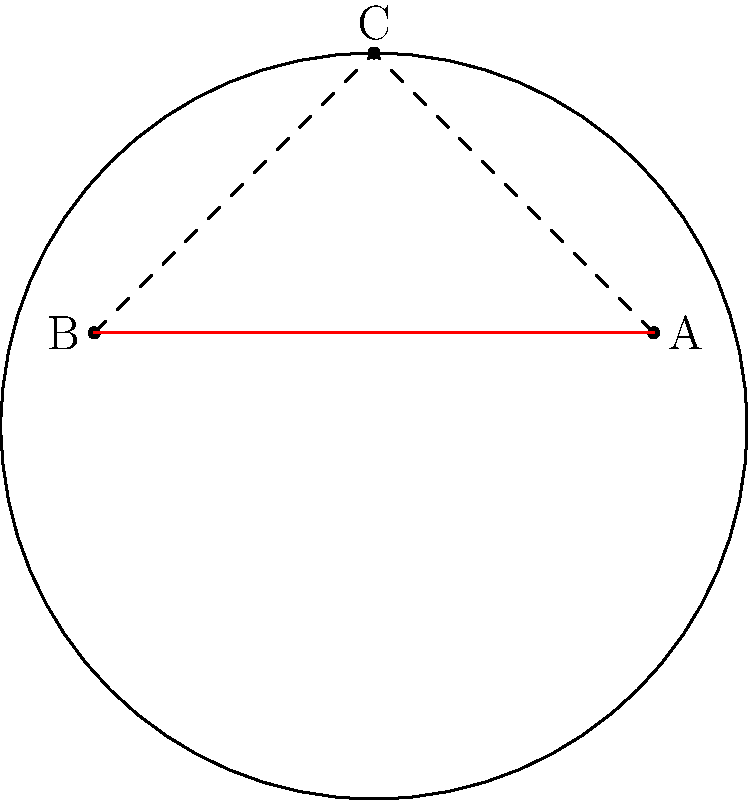A soccer player needs to run from point A to point B on a circular field. Which path should the player take to cover the shortest distance: running directly from A to B, or running from A to C and then from C to B? To determine the shortest path, we need to compare the lengths of two possible routes:

1. Direct path (A to B):
   This is a straight line across the circular field, represented by the red line in the diagram.

2. Path through C (A to C to B):
   This is represented by the dashed line in the diagram, consisting of two segments.

In topology, the shortest path between two points on a curved surface is called a geodesic. On a flat surface, the geodesic is always a straight line. However, on a curved surface like a sphere (which our circular field approximates), the geodesic can be a curved path.

In this case, despite the field being curved, the shortest path is still the straight line from A to B. This is because:

1. The curvature of the field is not significant enough to make a curved path shorter.
2. The direct path (A to B) is clearly shorter than the sum of the two segments (A to C plus C to B).

The straight line minimizes the distance traveled, allowing the player to rely on their physical strength and athleticism to cover the distance as quickly as possible.
Answer: The direct path from A to B 